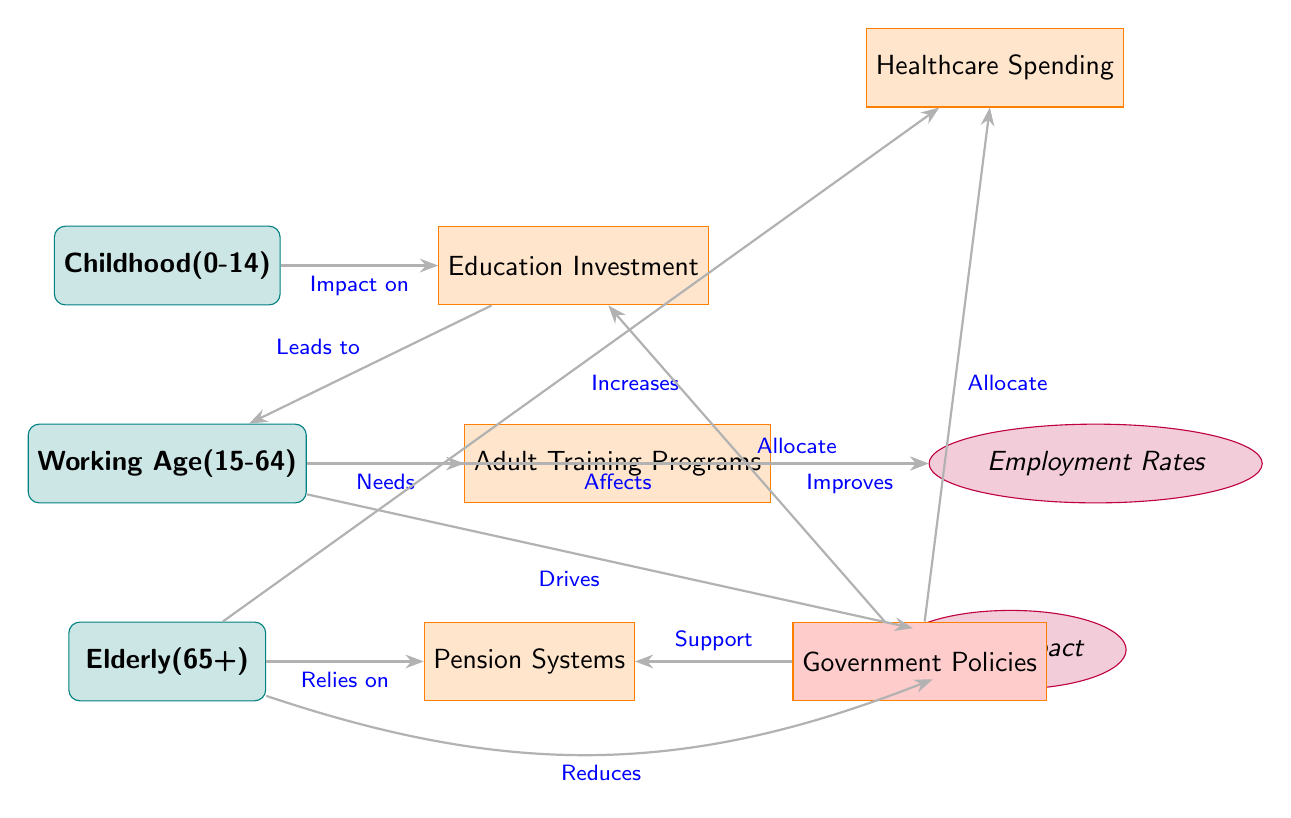What is the age range for the 'Working Age' demographic? The 'Working Age' demographic is indicated in the diagram as the group aged from 15 to 64 years.
Answer: 15-64 How many policies are represented in the diagram? The diagram displays a total of four policy nodes: Education Investment, Adult Training Programs, Pension Systems, and Healthcare Spending.
Answer: 4 Which age group requires training programs? The 'Working Age' group is depicted as needing training programs, indicated by the edge connecting 'Working Age' to 'Adult Training Programs'.
Answer: Working Age What impact does the 'Working Age' have on GDP? According to the flow in the diagram, 'Working Age' is shown to drive GDP, as represented by the edge connecting 'Working Age' to 'GDP Impact'.
Answer: Drives What happens to GDP when the elderly increase? The diagram indicates that an increase in the elderly demographic leads to a reduction in GDP, as shown by the edge pointing from 'Elderly' to 'GDP Impact' with the label "Reduces".
Answer: Reduces What does government allocate to education based on the diagram? The diagram shows a direct connection from 'Government Policies' to 'Education Investment', indicating that government policies allocate resources to education.
Answer: Allocate Which policy is related to employment rates? 'Adult Training Programs', connected by an edge to 'Employment Rates', is identified as the policy that improves employment rates.
Answer: Adult Training Programs How does education impact the working age population? The diagram reveals that education investment leads to an increase in the working age population, represented by the directed edge from 'Education Investment' to 'Working Age'.
Answer: Leads to What is the relationship between elderly care and healthcare spending? According to the diagram, there is a direct increase in healthcare spending in relation to the elderly, so the relationship is that the elderly increases healthcare spending.
Answer: Increases What policy supports pension systems? The connection from 'Government Policies' to 'Pension Systems' labels this relationship as a support from the government, indicating that government policies support pension systems.
Answer: Support 